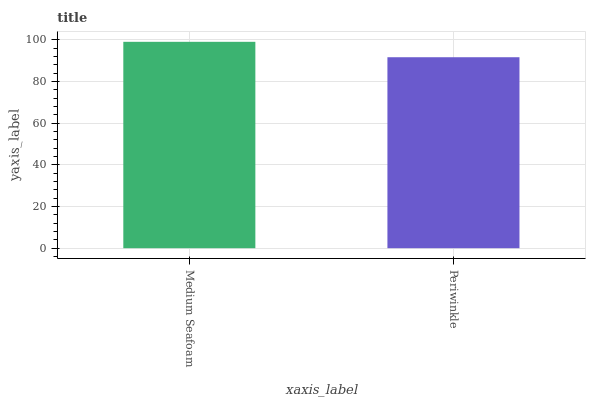Is Periwinkle the minimum?
Answer yes or no. Yes. Is Medium Seafoam the maximum?
Answer yes or no. Yes. Is Periwinkle the maximum?
Answer yes or no. No. Is Medium Seafoam greater than Periwinkle?
Answer yes or no. Yes. Is Periwinkle less than Medium Seafoam?
Answer yes or no. Yes. Is Periwinkle greater than Medium Seafoam?
Answer yes or no. No. Is Medium Seafoam less than Periwinkle?
Answer yes or no. No. Is Medium Seafoam the high median?
Answer yes or no. Yes. Is Periwinkle the low median?
Answer yes or no. Yes. Is Periwinkle the high median?
Answer yes or no. No. Is Medium Seafoam the low median?
Answer yes or no. No. 